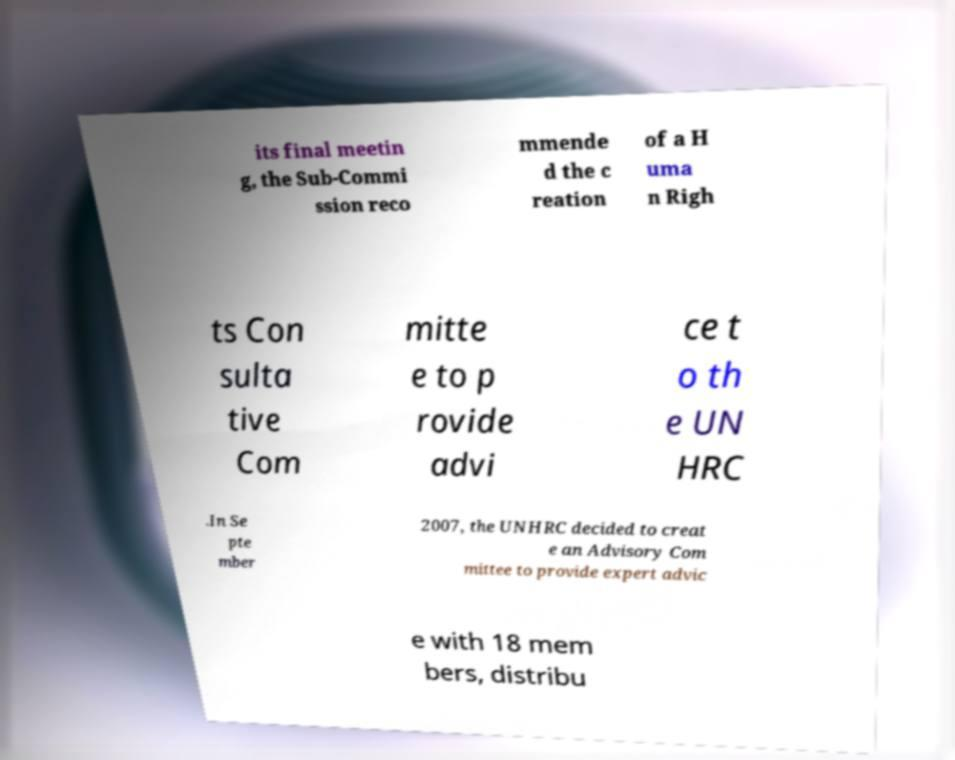For documentation purposes, I need the text within this image transcribed. Could you provide that? its final meetin g, the Sub-Commi ssion reco mmende d the c reation of a H uma n Righ ts Con sulta tive Com mitte e to p rovide advi ce t o th e UN HRC .In Se pte mber 2007, the UNHRC decided to creat e an Advisory Com mittee to provide expert advic e with 18 mem bers, distribu 